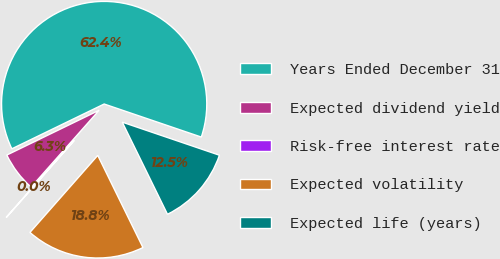<chart> <loc_0><loc_0><loc_500><loc_500><pie_chart><fcel>Years Ended December 31<fcel>Expected dividend yield<fcel>Risk-free interest rate<fcel>Expected volatility<fcel>Expected life (years)<nl><fcel>62.41%<fcel>6.28%<fcel>0.04%<fcel>18.75%<fcel>12.52%<nl></chart> 